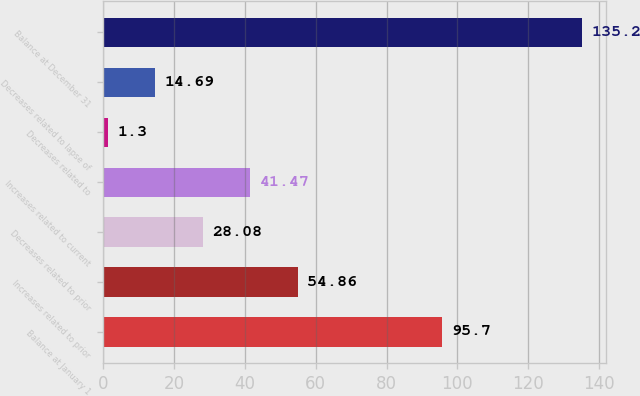Convert chart. <chart><loc_0><loc_0><loc_500><loc_500><bar_chart><fcel>Balance at January 1<fcel>Increases related to prior<fcel>Decreases related to prior<fcel>Increases related to current<fcel>Decreases related to<fcel>Decreases related to lapse of<fcel>Balance at December 31<nl><fcel>95.7<fcel>54.86<fcel>28.08<fcel>41.47<fcel>1.3<fcel>14.69<fcel>135.2<nl></chart> 